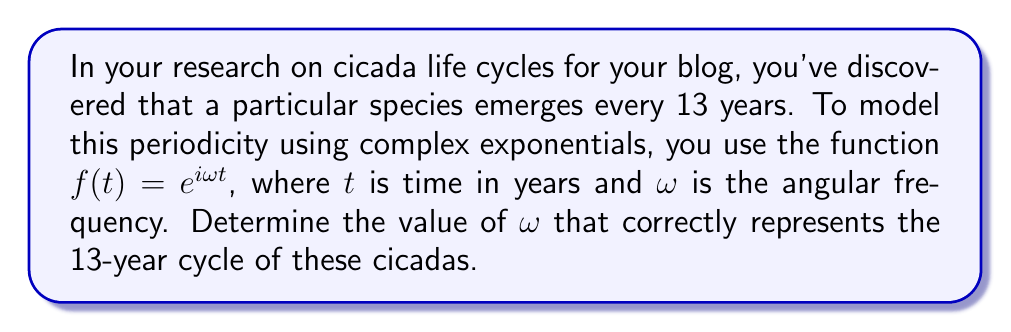Can you solve this math problem? To solve this problem, we'll follow these steps:

1) The general form of a complex exponential is $f(t) = e^{i\omega t}$, where $\omega$ is the angular frequency.

2) For a periodic function, we know that:
   $$f(t) = f(t + T)$$
   where $T$ is the period.

3) In this case, $T = 13$ years. Let's apply this to our function:
   $$e^{i\omega t} = e^{i\omega (t+13)}$$

4) Expanding the right side:
   $$e^{i\omega t} = e^{i\omega t} \cdot e^{i\omega 13}$$

5) For this equality to hold true for all $t$, we must have:
   $$e^{i\omega 13} = 1$$

6) We know from Euler's formula that $e^{i2\pi} = 1$. So, we need:
   $$\omega 13 = 2\pi$$

7) Solving for $\omega$:
   $$\omega = \frac{2\pi}{13}$$

This value of $\omega$ ensures that the function completes one full cycle every 13 years, matching the cicada's life cycle.
Answer: $\omega = \frac{2\pi}{13}$ 